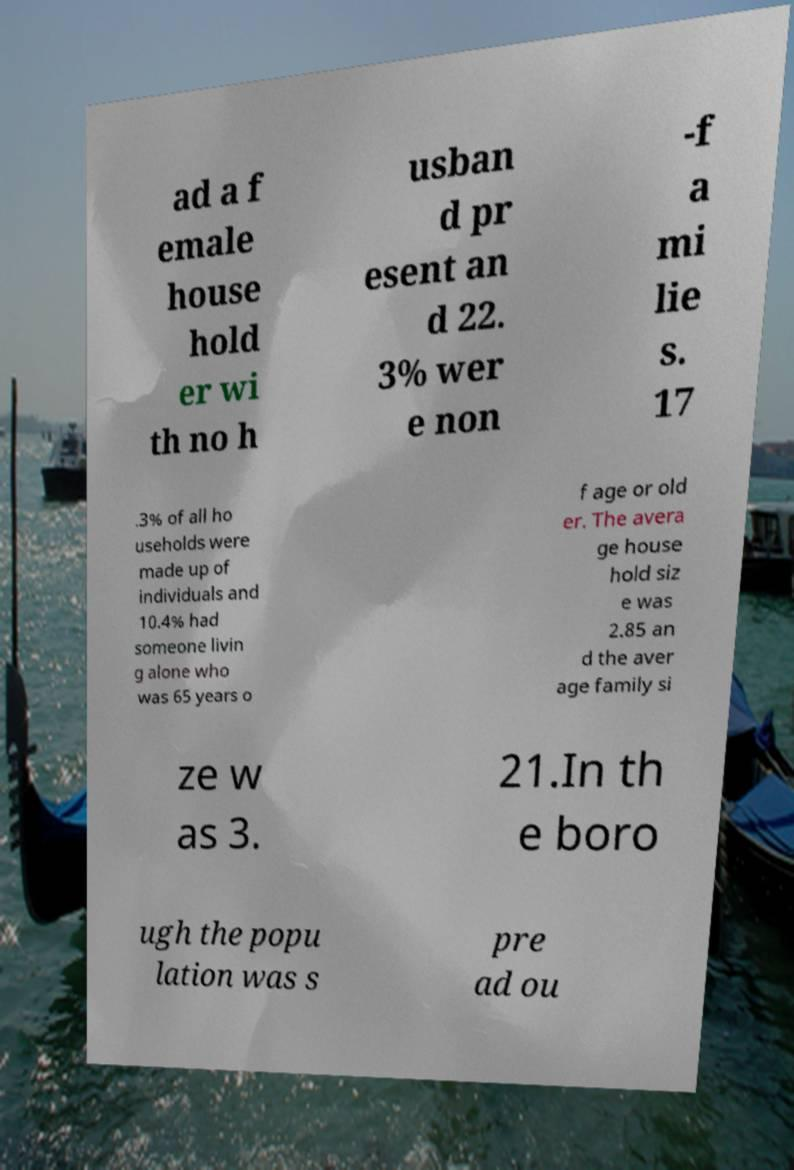Please identify and transcribe the text found in this image. ad a f emale house hold er wi th no h usban d pr esent an d 22. 3% wer e non -f a mi lie s. 17 .3% of all ho useholds were made up of individuals and 10.4% had someone livin g alone who was 65 years o f age or old er. The avera ge house hold siz e was 2.85 an d the aver age family si ze w as 3. 21.In th e boro ugh the popu lation was s pre ad ou 